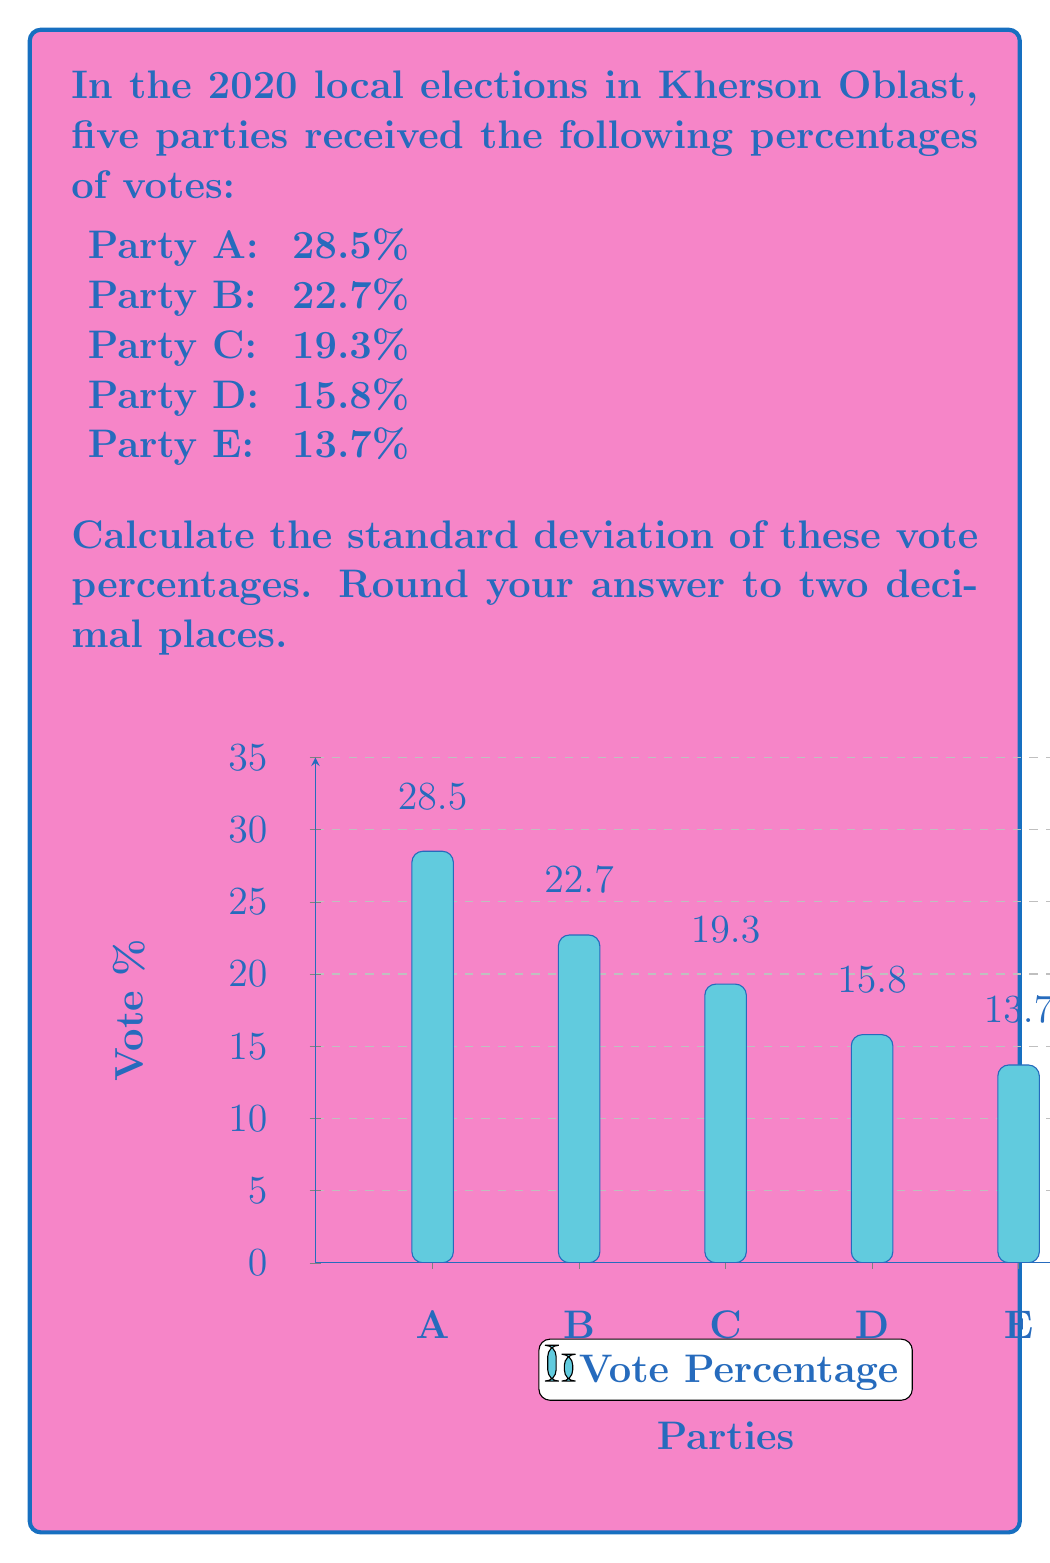Give your solution to this math problem. To calculate the standard deviation, we'll follow these steps:

1) Calculate the mean (average) of the percentages:

$\mu = \frac{28.5 + 22.7 + 19.3 + 15.8 + 13.7}{5} = 20$

2) Calculate the squared differences from the mean:

For Party A: $(28.5 - 20)^2 = 72.25$
For Party B: $(22.7 - 20)^2 = 7.29$
For Party C: $(19.3 - 20)^2 = 0.49$
For Party D: $(15.8 - 20)^2 = 17.64$
For Party E: $(13.7 - 20)^2 = 39.69$

3) Calculate the average of these squared differences:

$\frac{72.25 + 7.29 + 0.49 + 17.64 + 39.69}{5} = 27.472$

4) Take the square root of this average to get the standard deviation:

$$\sigma = \sqrt{27.472} = 5.2413...$$

5) Rounding to two decimal places:

$\sigma \approx 5.24$

This standard deviation indicates the average distance of each party's vote percentage from the mean, giving us a measure of the spread or variability in the voting patterns.
Answer: $5.24$ 